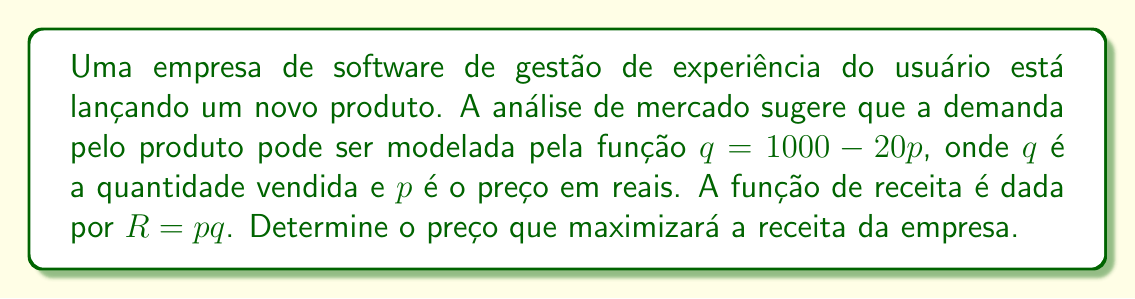Help me with this question. 1) Primeiro, substituímos a função de demanda na função de receita:
   $R = p(1000 - 20p)$
   $R = 1000p - 20p^2$

2) Para encontrar o máximo, derivamos a função de receita em relação a $p$:
   $\frac{dR}{dp} = 1000 - 40p$

3) Igualamos a derivada a zero para encontrar o ponto crítico:
   $1000 - 40p = 0$
   $40p = 1000$
   $p = 25$

4) Para confirmar que este é um máximo, verificamos a segunda derivada:
   $\frac{d^2R}{dp^2} = -40$
   Como é negativa, confirma-se que $p = 25$ é um máximo.

5) Portanto, o preço que maximiza a receita é R$ 25,00.

6) Para calcular a receita máxima:
   $q = 1000 - 20(25) = 500$
   $R_{max} = 25 * 500 = 12500$

Assim, a receita máxima é R$ 12.500,00.
Answer: R$ 25,00 